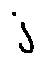<formula> <loc_0><loc_0><loc_500><loc_500>j</formula> 